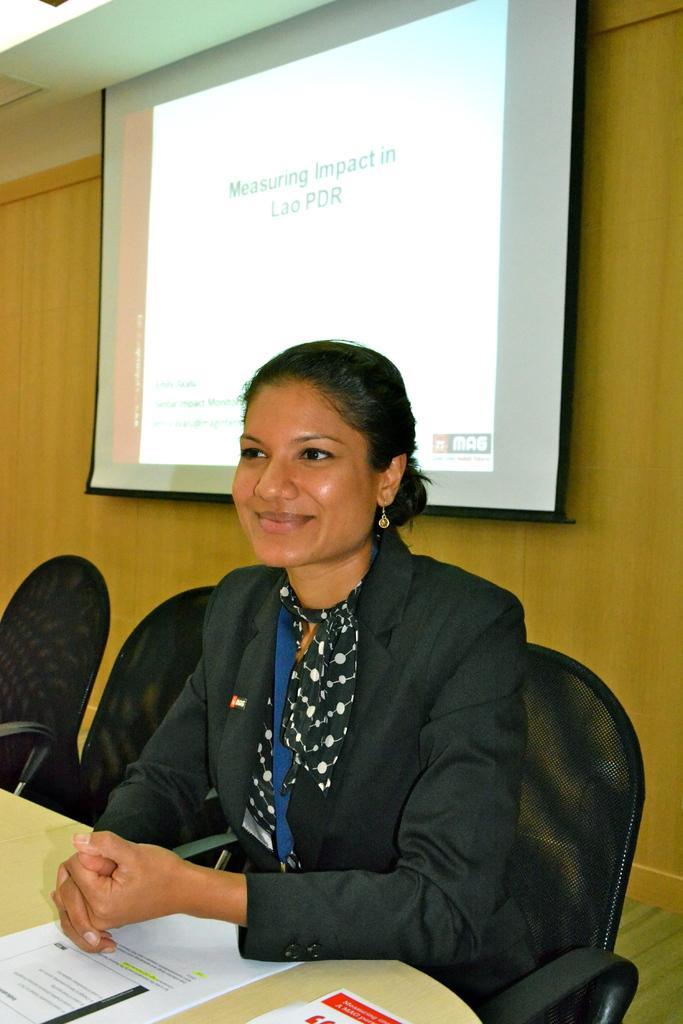In one or two sentences, can you explain what this image depicts? In this picture we can see a woman wearing a blazer and sitting on a chair and smiling and in front of her we can see papers on the table and at the back of her we can see a screen, wall. 